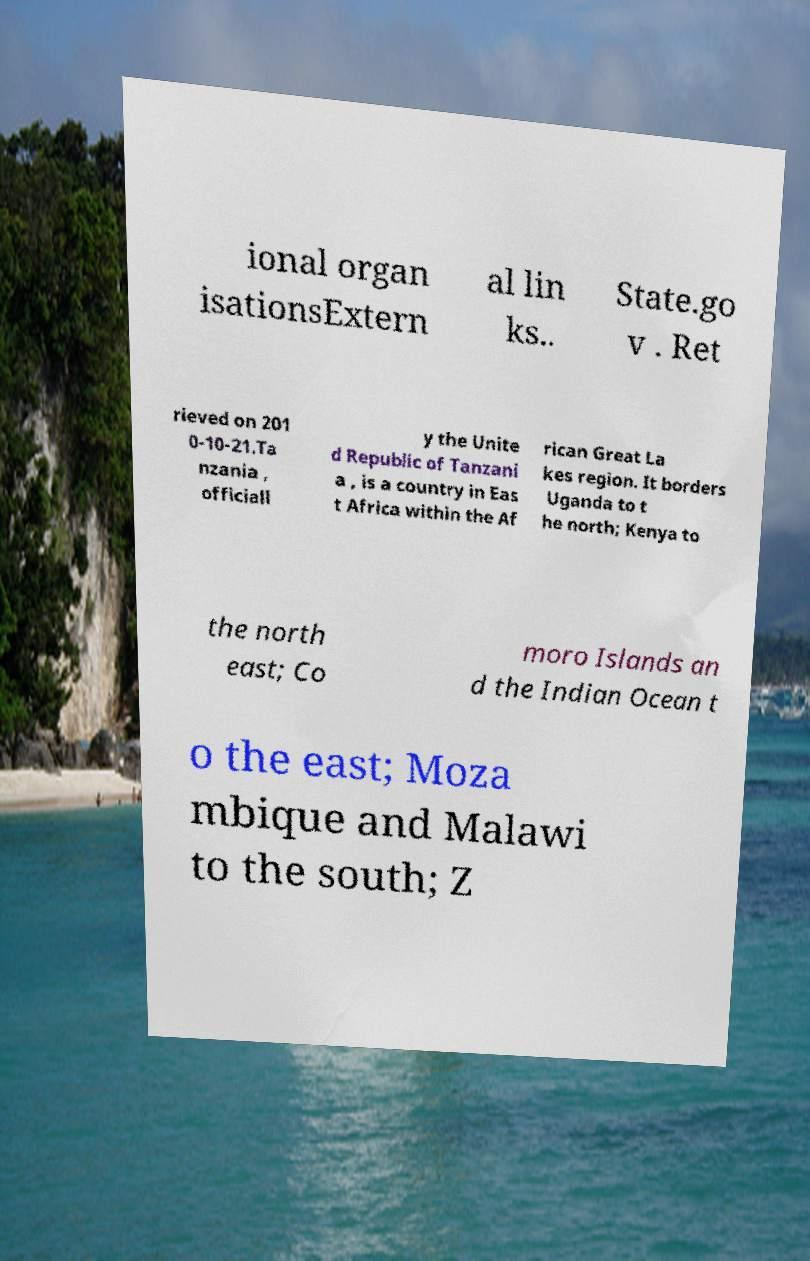Please read and relay the text visible in this image. What does it say? ional organ isationsExtern al lin ks.. State.go v . Ret rieved on 201 0-10-21.Ta nzania , officiall y the Unite d Republic of Tanzani a , is a country in Eas t Africa within the Af rican Great La kes region. It borders Uganda to t he north; Kenya to the north east; Co moro Islands an d the Indian Ocean t o the east; Moza mbique and Malawi to the south; Z 